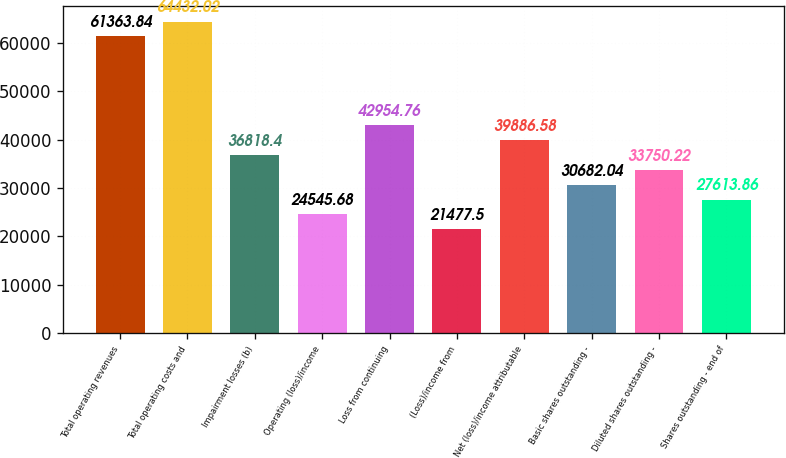Convert chart to OTSL. <chart><loc_0><loc_0><loc_500><loc_500><bar_chart><fcel>Total operating revenues<fcel>Total operating costs and<fcel>Impairment losses (b)<fcel>Operating (loss)/income<fcel>Loss from continuing<fcel>(Loss)/income from<fcel>Net (loss)/income attributable<fcel>Basic shares outstanding -<fcel>Diluted shares outstanding -<fcel>Shares outstanding - end of<nl><fcel>61363.8<fcel>64432<fcel>36818.4<fcel>24545.7<fcel>42954.8<fcel>21477.5<fcel>39886.6<fcel>30682<fcel>33750.2<fcel>27613.9<nl></chart> 